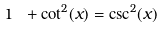Convert formula to latex. <formula><loc_0><loc_0><loc_500><loc_500>1 \ + \cot ^ { 2 } ( x ) = \csc ^ { 2 } ( x )</formula> 